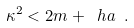Convert formula to latex. <formula><loc_0><loc_0><loc_500><loc_500>\kappa ^ { 2 } < { 2 m + \ h a } \ .</formula> 